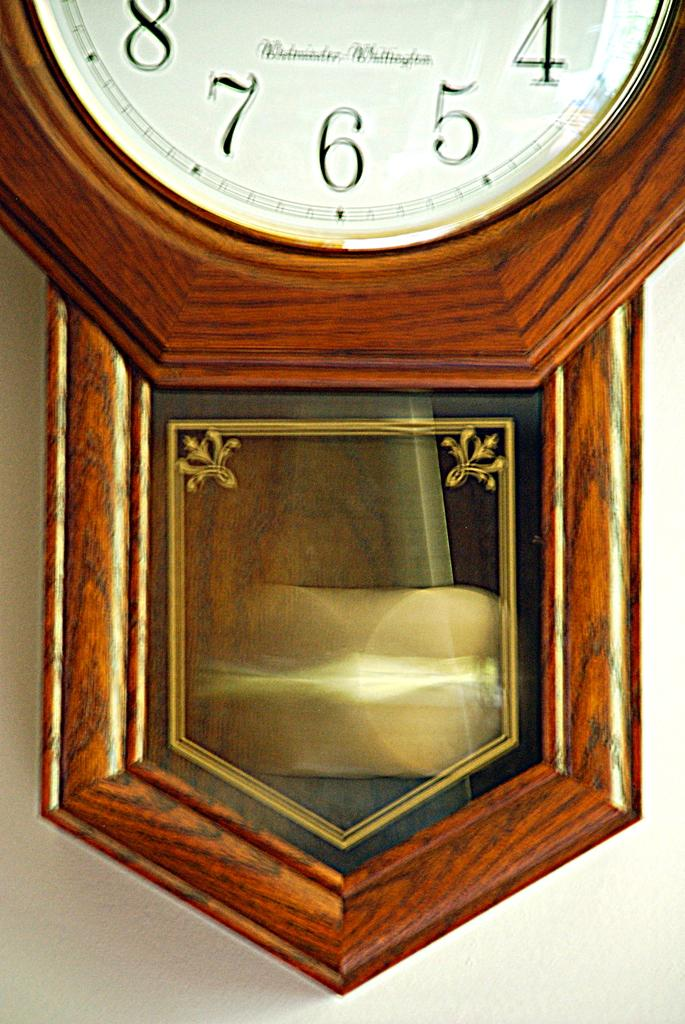<image>
Summarize the visual content of the image. A wall clock displays the numbers 4, 5, 6, 7 and 8. 